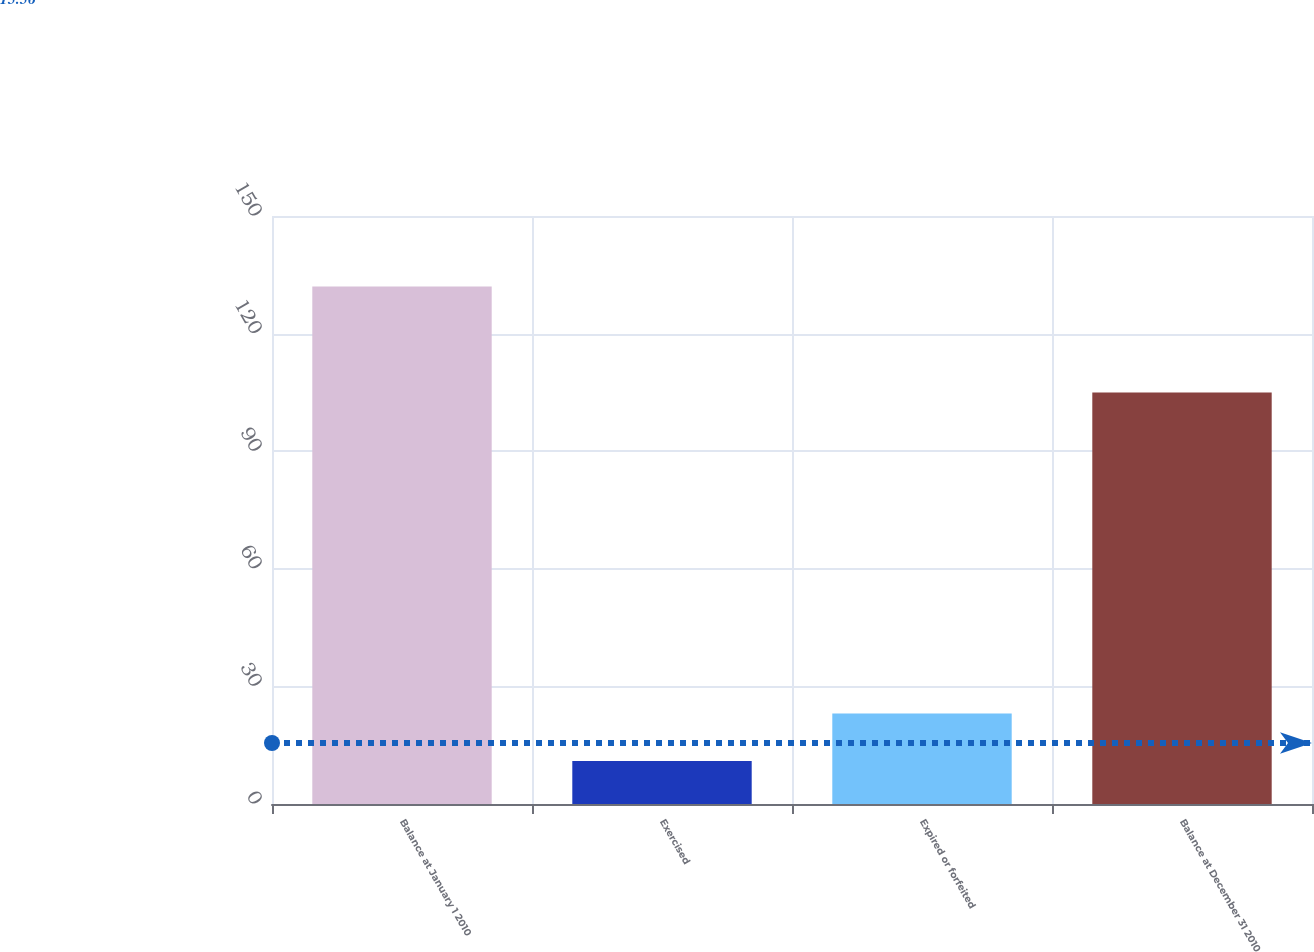Convert chart. <chart><loc_0><loc_0><loc_500><loc_500><bar_chart><fcel>Balance at January 1 2010<fcel>Exercised<fcel>Expired or forfeited<fcel>Balance at December 31 2010<nl><fcel>132<fcel>11<fcel>23.1<fcel>105<nl></chart> 